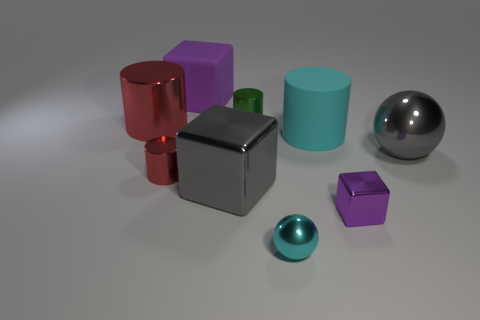The thing that is the same color as the big metallic cube is what size?
Keep it short and to the point. Large. Is there a shiny ball of the same color as the large matte cylinder?
Your answer should be compact. Yes. How many other things are the same shape as the large red metal object?
Your answer should be compact. 3. There is a large metal thing that is behind the gray ball; what is its shape?
Make the answer very short. Cylinder. There is a big red thing; is it the same shape as the small thing behind the cyan matte thing?
Offer a very short reply. Yes. There is a shiny cylinder that is on the right side of the large red metal object and behind the large shiny sphere; how big is it?
Give a very brief answer. Small. There is a large shiny thing that is both left of the cyan metallic object and behind the tiny red metallic cylinder; what is its color?
Your answer should be very brief. Red. Are there fewer gray metallic blocks right of the gray metallic sphere than tiny green shiny cylinders that are right of the big red object?
Give a very brief answer. Yes. Is there anything else that has the same color as the large metal sphere?
Provide a short and direct response. Yes. What shape is the large cyan rubber object?
Provide a short and direct response. Cylinder. 